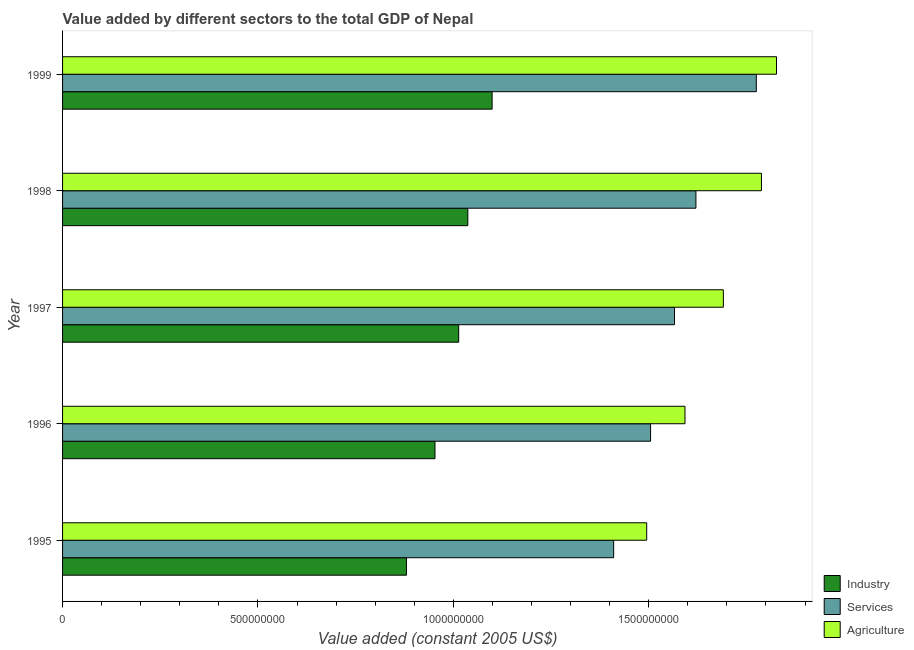How many groups of bars are there?
Provide a short and direct response. 5. Are the number of bars per tick equal to the number of legend labels?
Offer a terse response. Yes. Are the number of bars on each tick of the Y-axis equal?
Provide a short and direct response. Yes. What is the label of the 2nd group of bars from the top?
Keep it short and to the point. 1998. In how many cases, is the number of bars for a given year not equal to the number of legend labels?
Keep it short and to the point. 0. What is the value added by services in 1998?
Offer a very short reply. 1.62e+09. Across all years, what is the maximum value added by services?
Make the answer very short. 1.78e+09. Across all years, what is the minimum value added by industrial sector?
Ensure brevity in your answer.  8.80e+08. What is the total value added by services in the graph?
Provide a succinct answer. 7.88e+09. What is the difference between the value added by agricultural sector in 1995 and that in 1999?
Your answer should be compact. -3.32e+08. What is the difference between the value added by services in 1997 and the value added by agricultural sector in 1996?
Offer a very short reply. -2.68e+07. What is the average value added by services per year?
Provide a succinct answer. 1.58e+09. In the year 1997, what is the difference between the value added by agricultural sector and value added by services?
Your answer should be very brief. 1.25e+08. In how many years, is the value added by agricultural sector greater than 1200000000 US$?
Offer a very short reply. 5. What is the ratio of the value added by agricultural sector in 1996 to that in 1997?
Your response must be concise. 0.94. Is the difference between the value added by industrial sector in 1996 and 1998 greater than the difference between the value added by agricultural sector in 1996 and 1998?
Keep it short and to the point. Yes. What is the difference between the highest and the second highest value added by industrial sector?
Ensure brevity in your answer.  6.21e+07. What is the difference between the highest and the lowest value added by agricultural sector?
Your answer should be very brief. 3.32e+08. In how many years, is the value added by industrial sector greater than the average value added by industrial sector taken over all years?
Offer a very short reply. 3. Is the sum of the value added by services in 1998 and 1999 greater than the maximum value added by industrial sector across all years?
Ensure brevity in your answer.  Yes. What does the 1st bar from the top in 1997 represents?
Provide a succinct answer. Agriculture. What does the 2nd bar from the bottom in 1996 represents?
Make the answer very short. Services. Is it the case that in every year, the sum of the value added by industrial sector and value added by services is greater than the value added by agricultural sector?
Give a very brief answer. Yes. How many bars are there?
Make the answer very short. 15. Are all the bars in the graph horizontal?
Offer a terse response. Yes. What is the difference between two consecutive major ticks on the X-axis?
Offer a terse response. 5.00e+08. Does the graph contain any zero values?
Make the answer very short. No. Does the graph contain grids?
Ensure brevity in your answer.  No. How are the legend labels stacked?
Provide a short and direct response. Vertical. What is the title of the graph?
Your answer should be very brief. Value added by different sectors to the total GDP of Nepal. What is the label or title of the X-axis?
Give a very brief answer. Value added (constant 2005 US$). What is the Value added (constant 2005 US$) of Industry in 1995?
Keep it short and to the point. 8.80e+08. What is the Value added (constant 2005 US$) of Services in 1995?
Make the answer very short. 1.41e+09. What is the Value added (constant 2005 US$) in Agriculture in 1995?
Keep it short and to the point. 1.49e+09. What is the Value added (constant 2005 US$) of Industry in 1996?
Offer a very short reply. 9.53e+08. What is the Value added (constant 2005 US$) in Services in 1996?
Give a very brief answer. 1.50e+09. What is the Value added (constant 2005 US$) in Agriculture in 1996?
Offer a terse response. 1.59e+09. What is the Value added (constant 2005 US$) of Industry in 1997?
Give a very brief answer. 1.01e+09. What is the Value added (constant 2005 US$) in Services in 1997?
Ensure brevity in your answer.  1.57e+09. What is the Value added (constant 2005 US$) in Agriculture in 1997?
Provide a succinct answer. 1.69e+09. What is the Value added (constant 2005 US$) of Industry in 1998?
Keep it short and to the point. 1.04e+09. What is the Value added (constant 2005 US$) of Services in 1998?
Make the answer very short. 1.62e+09. What is the Value added (constant 2005 US$) in Agriculture in 1998?
Your answer should be compact. 1.79e+09. What is the Value added (constant 2005 US$) in Industry in 1999?
Your answer should be very brief. 1.10e+09. What is the Value added (constant 2005 US$) of Services in 1999?
Give a very brief answer. 1.78e+09. What is the Value added (constant 2005 US$) in Agriculture in 1999?
Make the answer very short. 1.83e+09. Across all years, what is the maximum Value added (constant 2005 US$) of Industry?
Give a very brief answer. 1.10e+09. Across all years, what is the maximum Value added (constant 2005 US$) in Services?
Your response must be concise. 1.78e+09. Across all years, what is the maximum Value added (constant 2005 US$) in Agriculture?
Make the answer very short. 1.83e+09. Across all years, what is the minimum Value added (constant 2005 US$) of Industry?
Give a very brief answer. 8.80e+08. Across all years, what is the minimum Value added (constant 2005 US$) of Services?
Ensure brevity in your answer.  1.41e+09. Across all years, what is the minimum Value added (constant 2005 US$) in Agriculture?
Ensure brevity in your answer.  1.49e+09. What is the total Value added (constant 2005 US$) in Industry in the graph?
Offer a terse response. 4.98e+09. What is the total Value added (constant 2005 US$) of Services in the graph?
Make the answer very short. 7.88e+09. What is the total Value added (constant 2005 US$) in Agriculture in the graph?
Offer a terse response. 8.39e+09. What is the difference between the Value added (constant 2005 US$) of Industry in 1995 and that in 1996?
Your answer should be compact. -7.31e+07. What is the difference between the Value added (constant 2005 US$) of Services in 1995 and that in 1996?
Provide a succinct answer. -9.44e+07. What is the difference between the Value added (constant 2005 US$) in Agriculture in 1995 and that in 1996?
Provide a short and direct response. -9.80e+07. What is the difference between the Value added (constant 2005 US$) of Industry in 1995 and that in 1997?
Ensure brevity in your answer.  -1.34e+08. What is the difference between the Value added (constant 2005 US$) in Services in 1995 and that in 1997?
Provide a short and direct response. -1.56e+08. What is the difference between the Value added (constant 2005 US$) of Agriculture in 1995 and that in 1997?
Provide a succinct answer. -1.96e+08. What is the difference between the Value added (constant 2005 US$) of Industry in 1995 and that in 1998?
Provide a succinct answer. -1.57e+08. What is the difference between the Value added (constant 2005 US$) of Services in 1995 and that in 1998?
Give a very brief answer. -2.11e+08. What is the difference between the Value added (constant 2005 US$) of Agriculture in 1995 and that in 1998?
Ensure brevity in your answer.  -2.94e+08. What is the difference between the Value added (constant 2005 US$) of Industry in 1995 and that in 1999?
Your answer should be very brief. -2.19e+08. What is the difference between the Value added (constant 2005 US$) in Services in 1995 and that in 1999?
Offer a very short reply. -3.65e+08. What is the difference between the Value added (constant 2005 US$) of Agriculture in 1995 and that in 1999?
Your answer should be compact. -3.32e+08. What is the difference between the Value added (constant 2005 US$) in Industry in 1996 and that in 1997?
Give a very brief answer. -6.06e+07. What is the difference between the Value added (constant 2005 US$) of Services in 1996 and that in 1997?
Your answer should be compact. -6.12e+07. What is the difference between the Value added (constant 2005 US$) of Agriculture in 1996 and that in 1997?
Your answer should be compact. -9.82e+07. What is the difference between the Value added (constant 2005 US$) in Industry in 1996 and that in 1998?
Offer a terse response. -8.41e+07. What is the difference between the Value added (constant 2005 US$) of Services in 1996 and that in 1998?
Offer a terse response. -1.16e+08. What is the difference between the Value added (constant 2005 US$) in Agriculture in 1996 and that in 1998?
Ensure brevity in your answer.  -1.96e+08. What is the difference between the Value added (constant 2005 US$) of Industry in 1996 and that in 1999?
Provide a succinct answer. -1.46e+08. What is the difference between the Value added (constant 2005 US$) in Services in 1996 and that in 1999?
Your answer should be compact. -2.71e+08. What is the difference between the Value added (constant 2005 US$) in Agriculture in 1996 and that in 1999?
Your answer should be very brief. -2.34e+08. What is the difference between the Value added (constant 2005 US$) in Industry in 1997 and that in 1998?
Keep it short and to the point. -2.34e+07. What is the difference between the Value added (constant 2005 US$) of Services in 1997 and that in 1998?
Your answer should be compact. -5.48e+07. What is the difference between the Value added (constant 2005 US$) in Agriculture in 1997 and that in 1998?
Keep it short and to the point. -9.75e+07. What is the difference between the Value added (constant 2005 US$) in Industry in 1997 and that in 1999?
Provide a short and direct response. -8.55e+07. What is the difference between the Value added (constant 2005 US$) in Services in 1997 and that in 1999?
Offer a very short reply. -2.09e+08. What is the difference between the Value added (constant 2005 US$) of Agriculture in 1997 and that in 1999?
Your answer should be very brief. -1.36e+08. What is the difference between the Value added (constant 2005 US$) of Industry in 1998 and that in 1999?
Keep it short and to the point. -6.21e+07. What is the difference between the Value added (constant 2005 US$) in Services in 1998 and that in 1999?
Make the answer very short. -1.55e+08. What is the difference between the Value added (constant 2005 US$) of Agriculture in 1998 and that in 1999?
Provide a short and direct response. -3.85e+07. What is the difference between the Value added (constant 2005 US$) in Industry in 1995 and the Value added (constant 2005 US$) in Services in 1996?
Give a very brief answer. -6.25e+08. What is the difference between the Value added (constant 2005 US$) of Industry in 1995 and the Value added (constant 2005 US$) of Agriculture in 1996?
Keep it short and to the point. -7.13e+08. What is the difference between the Value added (constant 2005 US$) of Services in 1995 and the Value added (constant 2005 US$) of Agriculture in 1996?
Your answer should be compact. -1.83e+08. What is the difference between the Value added (constant 2005 US$) in Industry in 1995 and the Value added (constant 2005 US$) in Services in 1997?
Ensure brevity in your answer.  -6.86e+08. What is the difference between the Value added (constant 2005 US$) in Industry in 1995 and the Value added (constant 2005 US$) in Agriculture in 1997?
Your answer should be compact. -8.11e+08. What is the difference between the Value added (constant 2005 US$) in Services in 1995 and the Value added (constant 2005 US$) in Agriculture in 1997?
Provide a short and direct response. -2.81e+08. What is the difference between the Value added (constant 2005 US$) in Industry in 1995 and the Value added (constant 2005 US$) in Services in 1998?
Your answer should be very brief. -7.41e+08. What is the difference between the Value added (constant 2005 US$) in Industry in 1995 and the Value added (constant 2005 US$) in Agriculture in 1998?
Provide a short and direct response. -9.08e+08. What is the difference between the Value added (constant 2005 US$) of Services in 1995 and the Value added (constant 2005 US$) of Agriculture in 1998?
Offer a very short reply. -3.78e+08. What is the difference between the Value added (constant 2005 US$) in Industry in 1995 and the Value added (constant 2005 US$) in Services in 1999?
Provide a succinct answer. -8.95e+08. What is the difference between the Value added (constant 2005 US$) of Industry in 1995 and the Value added (constant 2005 US$) of Agriculture in 1999?
Give a very brief answer. -9.47e+08. What is the difference between the Value added (constant 2005 US$) in Services in 1995 and the Value added (constant 2005 US$) in Agriculture in 1999?
Ensure brevity in your answer.  -4.17e+08. What is the difference between the Value added (constant 2005 US$) of Industry in 1996 and the Value added (constant 2005 US$) of Services in 1997?
Offer a terse response. -6.13e+08. What is the difference between the Value added (constant 2005 US$) of Industry in 1996 and the Value added (constant 2005 US$) of Agriculture in 1997?
Your answer should be very brief. -7.38e+08. What is the difference between the Value added (constant 2005 US$) in Services in 1996 and the Value added (constant 2005 US$) in Agriculture in 1997?
Ensure brevity in your answer.  -1.86e+08. What is the difference between the Value added (constant 2005 US$) in Industry in 1996 and the Value added (constant 2005 US$) in Services in 1998?
Make the answer very short. -6.68e+08. What is the difference between the Value added (constant 2005 US$) in Industry in 1996 and the Value added (constant 2005 US$) in Agriculture in 1998?
Ensure brevity in your answer.  -8.35e+08. What is the difference between the Value added (constant 2005 US$) in Services in 1996 and the Value added (constant 2005 US$) in Agriculture in 1998?
Offer a terse response. -2.84e+08. What is the difference between the Value added (constant 2005 US$) in Industry in 1996 and the Value added (constant 2005 US$) in Services in 1999?
Keep it short and to the point. -8.22e+08. What is the difference between the Value added (constant 2005 US$) of Industry in 1996 and the Value added (constant 2005 US$) of Agriculture in 1999?
Offer a terse response. -8.74e+08. What is the difference between the Value added (constant 2005 US$) of Services in 1996 and the Value added (constant 2005 US$) of Agriculture in 1999?
Provide a short and direct response. -3.22e+08. What is the difference between the Value added (constant 2005 US$) in Industry in 1997 and the Value added (constant 2005 US$) in Services in 1998?
Give a very brief answer. -6.07e+08. What is the difference between the Value added (constant 2005 US$) in Industry in 1997 and the Value added (constant 2005 US$) in Agriculture in 1998?
Ensure brevity in your answer.  -7.75e+08. What is the difference between the Value added (constant 2005 US$) of Services in 1997 and the Value added (constant 2005 US$) of Agriculture in 1998?
Offer a very short reply. -2.23e+08. What is the difference between the Value added (constant 2005 US$) of Industry in 1997 and the Value added (constant 2005 US$) of Services in 1999?
Your response must be concise. -7.62e+08. What is the difference between the Value added (constant 2005 US$) in Industry in 1997 and the Value added (constant 2005 US$) in Agriculture in 1999?
Make the answer very short. -8.13e+08. What is the difference between the Value added (constant 2005 US$) in Services in 1997 and the Value added (constant 2005 US$) in Agriculture in 1999?
Provide a succinct answer. -2.61e+08. What is the difference between the Value added (constant 2005 US$) in Industry in 1998 and the Value added (constant 2005 US$) in Services in 1999?
Your response must be concise. -7.38e+08. What is the difference between the Value added (constant 2005 US$) of Industry in 1998 and the Value added (constant 2005 US$) of Agriculture in 1999?
Give a very brief answer. -7.90e+08. What is the difference between the Value added (constant 2005 US$) in Services in 1998 and the Value added (constant 2005 US$) in Agriculture in 1999?
Ensure brevity in your answer.  -2.06e+08. What is the average Value added (constant 2005 US$) in Industry per year?
Provide a short and direct response. 9.97e+08. What is the average Value added (constant 2005 US$) in Services per year?
Offer a terse response. 1.58e+09. What is the average Value added (constant 2005 US$) in Agriculture per year?
Your answer should be very brief. 1.68e+09. In the year 1995, what is the difference between the Value added (constant 2005 US$) in Industry and Value added (constant 2005 US$) in Services?
Your response must be concise. -5.30e+08. In the year 1995, what is the difference between the Value added (constant 2005 US$) of Industry and Value added (constant 2005 US$) of Agriculture?
Give a very brief answer. -6.15e+08. In the year 1995, what is the difference between the Value added (constant 2005 US$) in Services and Value added (constant 2005 US$) in Agriculture?
Your answer should be compact. -8.45e+07. In the year 1996, what is the difference between the Value added (constant 2005 US$) of Industry and Value added (constant 2005 US$) of Services?
Your answer should be very brief. -5.52e+08. In the year 1996, what is the difference between the Value added (constant 2005 US$) of Industry and Value added (constant 2005 US$) of Agriculture?
Your answer should be compact. -6.40e+08. In the year 1996, what is the difference between the Value added (constant 2005 US$) in Services and Value added (constant 2005 US$) in Agriculture?
Offer a terse response. -8.81e+07. In the year 1997, what is the difference between the Value added (constant 2005 US$) of Industry and Value added (constant 2005 US$) of Services?
Make the answer very short. -5.52e+08. In the year 1997, what is the difference between the Value added (constant 2005 US$) of Industry and Value added (constant 2005 US$) of Agriculture?
Keep it short and to the point. -6.77e+08. In the year 1997, what is the difference between the Value added (constant 2005 US$) of Services and Value added (constant 2005 US$) of Agriculture?
Provide a succinct answer. -1.25e+08. In the year 1998, what is the difference between the Value added (constant 2005 US$) of Industry and Value added (constant 2005 US$) of Services?
Offer a terse response. -5.84e+08. In the year 1998, what is the difference between the Value added (constant 2005 US$) of Industry and Value added (constant 2005 US$) of Agriculture?
Provide a short and direct response. -7.51e+08. In the year 1998, what is the difference between the Value added (constant 2005 US$) of Services and Value added (constant 2005 US$) of Agriculture?
Your answer should be compact. -1.68e+08. In the year 1999, what is the difference between the Value added (constant 2005 US$) in Industry and Value added (constant 2005 US$) in Services?
Make the answer very short. -6.76e+08. In the year 1999, what is the difference between the Value added (constant 2005 US$) in Industry and Value added (constant 2005 US$) in Agriculture?
Keep it short and to the point. -7.28e+08. In the year 1999, what is the difference between the Value added (constant 2005 US$) in Services and Value added (constant 2005 US$) in Agriculture?
Give a very brief answer. -5.16e+07. What is the ratio of the Value added (constant 2005 US$) of Industry in 1995 to that in 1996?
Your response must be concise. 0.92. What is the ratio of the Value added (constant 2005 US$) in Services in 1995 to that in 1996?
Provide a short and direct response. 0.94. What is the ratio of the Value added (constant 2005 US$) of Agriculture in 1995 to that in 1996?
Provide a succinct answer. 0.94. What is the ratio of the Value added (constant 2005 US$) in Industry in 1995 to that in 1997?
Offer a very short reply. 0.87. What is the ratio of the Value added (constant 2005 US$) of Services in 1995 to that in 1997?
Keep it short and to the point. 0.9. What is the ratio of the Value added (constant 2005 US$) in Agriculture in 1995 to that in 1997?
Your answer should be very brief. 0.88. What is the ratio of the Value added (constant 2005 US$) of Industry in 1995 to that in 1998?
Keep it short and to the point. 0.85. What is the ratio of the Value added (constant 2005 US$) in Services in 1995 to that in 1998?
Provide a short and direct response. 0.87. What is the ratio of the Value added (constant 2005 US$) of Agriculture in 1995 to that in 1998?
Your answer should be very brief. 0.84. What is the ratio of the Value added (constant 2005 US$) in Industry in 1995 to that in 1999?
Your response must be concise. 0.8. What is the ratio of the Value added (constant 2005 US$) in Services in 1995 to that in 1999?
Provide a succinct answer. 0.79. What is the ratio of the Value added (constant 2005 US$) of Agriculture in 1995 to that in 1999?
Give a very brief answer. 0.82. What is the ratio of the Value added (constant 2005 US$) of Industry in 1996 to that in 1997?
Ensure brevity in your answer.  0.94. What is the ratio of the Value added (constant 2005 US$) of Services in 1996 to that in 1997?
Offer a very short reply. 0.96. What is the ratio of the Value added (constant 2005 US$) in Agriculture in 1996 to that in 1997?
Your response must be concise. 0.94. What is the ratio of the Value added (constant 2005 US$) of Industry in 1996 to that in 1998?
Your response must be concise. 0.92. What is the ratio of the Value added (constant 2005 US$) in Services in 1996 to that in 1998?
Offer a very short reply. 0.93. What is the ratio of the Value added (constant 2005 US$) of Agriculture in 1996 to that in 1998?
Your answer should be compact. 0.89. What is the ratio of the Value added (constant 2005 US$) of Industry in 1996 to that in 1999?
Offer a terse response. 0.87. What is the ratio of the Value added (constant 2005 US$) in Services in 1996 to that in 1999?
Your answer should be very brief. 0.85. What is the ratio of the Value added (constant 2005 US$) of Agriculture in 1996 to that in 1999?
Offer a terse response. 0.87. What is the ratio of the Value added (constant 2005 US$) of Industry in 1997 to that in 1998?
Offer a very short reply. 0.98. What is the ratio of the Value added (constant 2005 US$) of Services in 1997 to that in 1998?
Your response must be concise. 0.97. What is the ratio of the Value added (constant 2005 US$) in Agriculture in 1997 to that in 1998?
Your response must be concise. 0.95. What is the ratio of the Value added (constant 2005 US$) of Industry in 1997 to that in 1999?
Your answer should be compact. 0.92. What is the ratio of the Value added (constant 2005 US$) of Services in 1997 to that in 1999?
Offer a terse response. 0.88. What is the ratio of the Value added (constant 2005 US$) of Agriculture in 1997 to that in 1999?
Provide a succinct answer. 0.93. What is the ratio of the Value added (constant 2005 US$) of Industry in 1998 to that in 1999?
Offer a terse response. 0.94. What is the ratio of the Value added (constant 2005 US$) of Services in 1998 to that in 1999?
Provide a short and direct response. 0.91. What is the ratio of the Value added (constant 2005 US$) in Agriculture in 1998 to that in 1999?
Your answer should be very brief. 0.98. What is the difference between the highest and the second highest Value added (constant 2005 US$) in Industry?
Make the answer very short. 6.21e+07. What is the difference between the highest and the second highest Value added (constant 2005 US$) of Services?
Give a very brief answer. 1.55e+08. What is the difference between the highest and the second highest Value added (constant 2005 US$) of Agriculture?
Provide a short and direct response. 3.85e+07. What is the difference between the highest and the lowest Value added (constant 2005 US$) in Industry?
Your response must be concise. 2.19e+08. What is the difference between the highest and the lowest Value added (constant 2005 US$) in Services?
Offer a terse response. 3.65e+08. What is the difference between the highest and the lowest Value added (constant 2005 US$) of Agriculture?
Keep it short and to the point. 3.32e+08. 